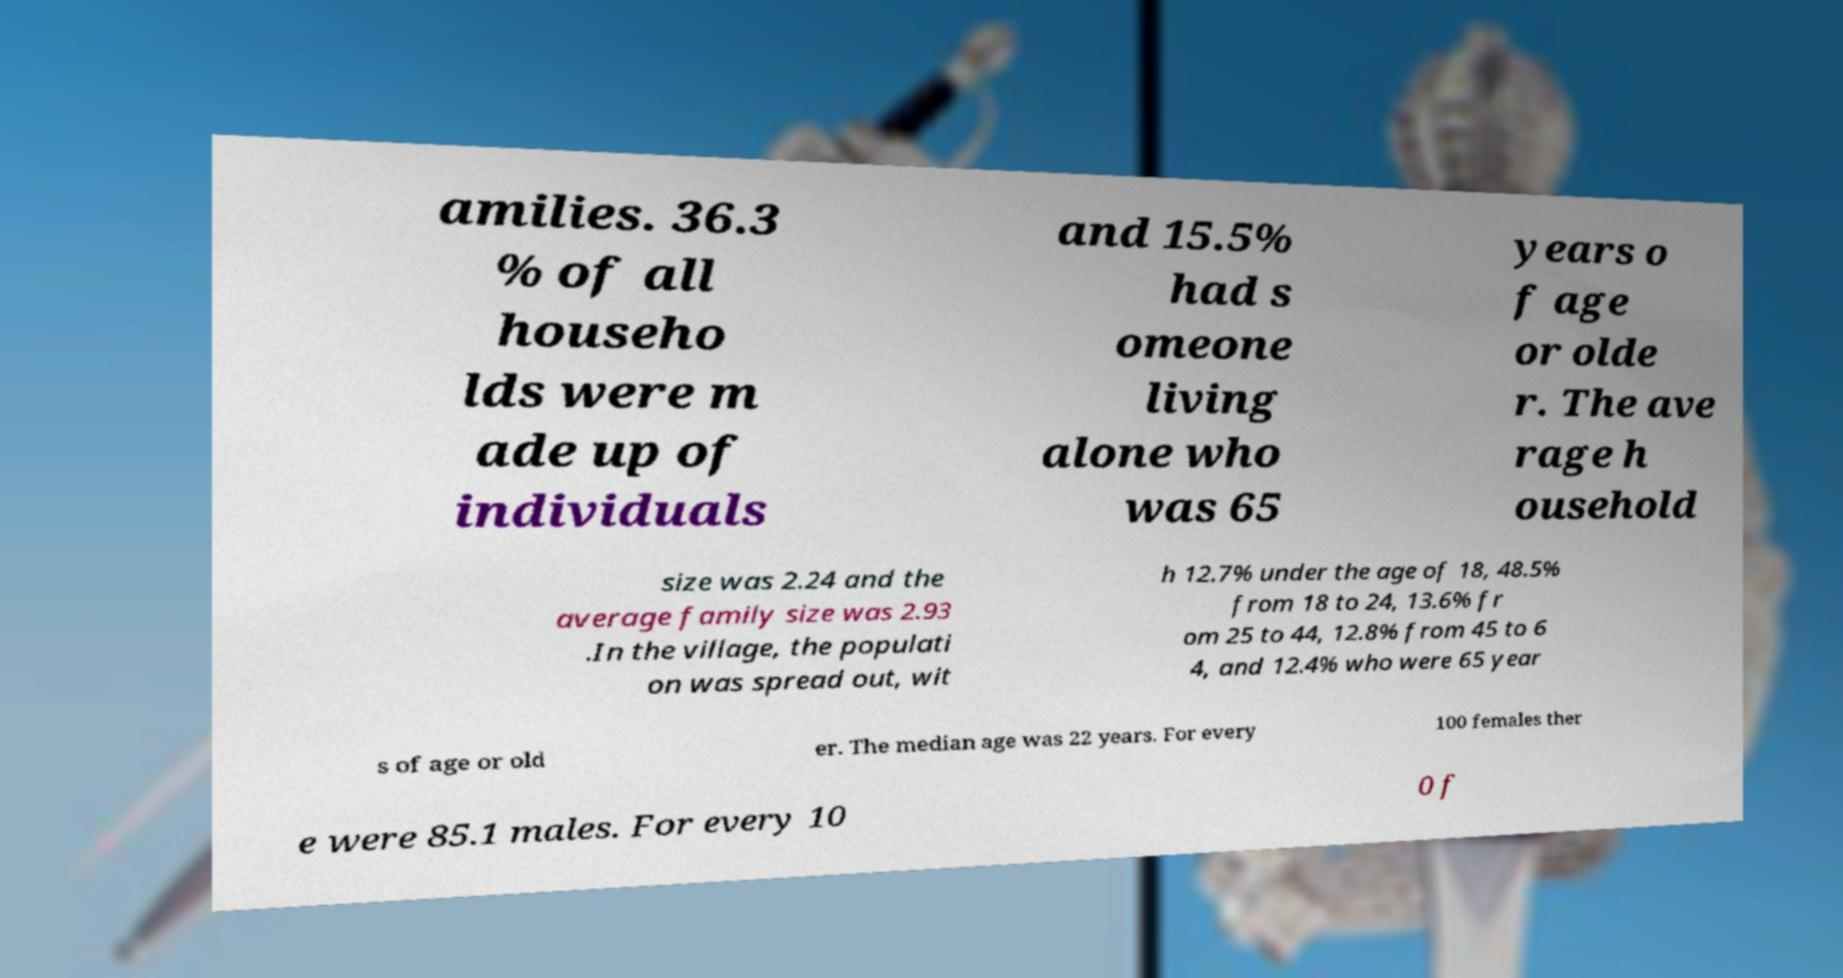Please read and relay the text visible in this image. What does it say? amilies. 36.3 % of all househo lds were m ade up of individuals and 15.5% had s omeone living alone who was 65 years o f age or olde r. The ave rage h ousehold size was 2.24 and the average family size was 2.93 .In the village, the populati on was spread out, wit h 12.7% under the age of 18, 48.5% from 18 to 24, 13.6% fr om 25 to 44, 12.8% from 45 to 6 4, and 12.4% who were 65 year s of age or old er. The median age was 22 years. For every 100 females ther e were 85.1 males. For every 10 0 f 